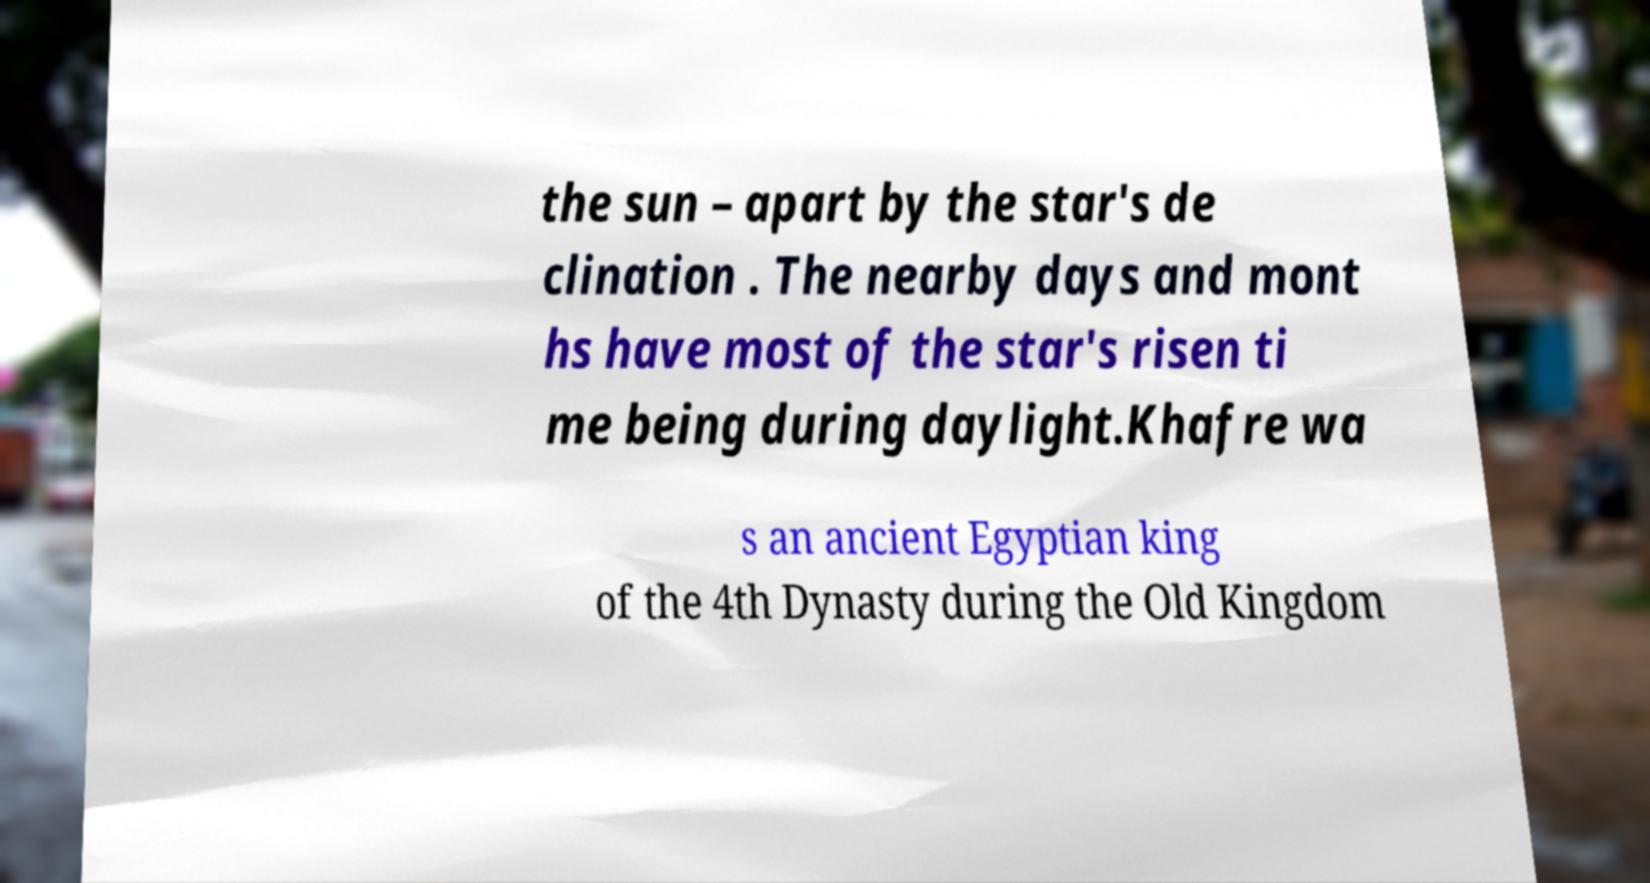Please identify and transcribe the text found in this image. the sun – apart by the star's de clination . The nearby days and mont hs have most of the star's risen ti me being during daylight.Khafre wa s an ancient Egyptian king of the 4th Dynasty during the Old Kingdom 